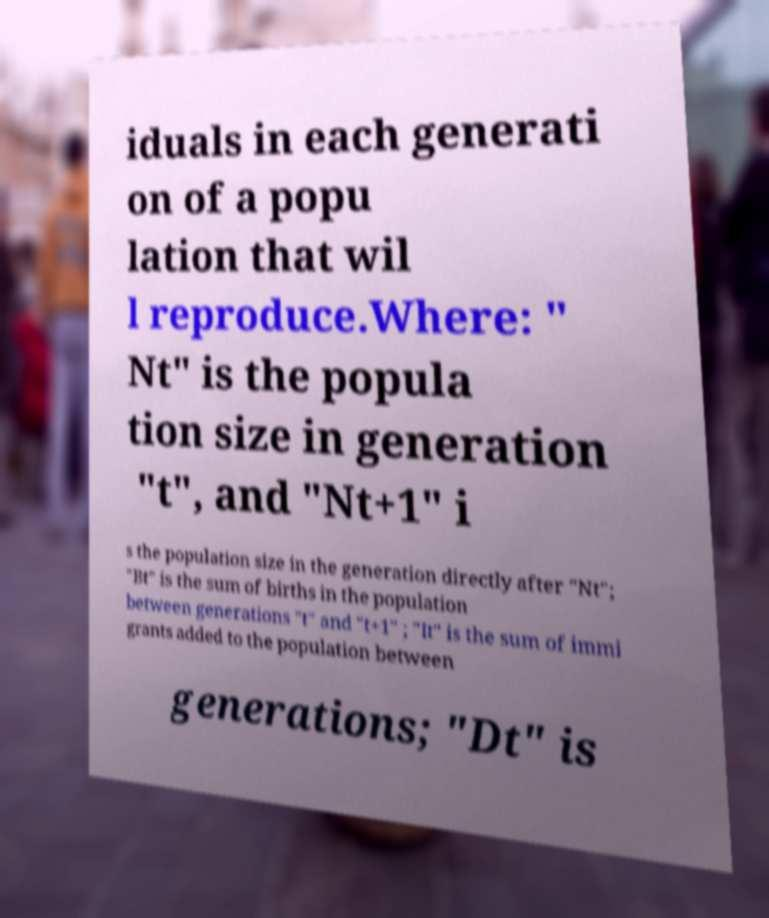What messages or text are displayed in this image? I need them in a readable, typed format. iduals in each generati on of a popu lation that wil l reproduce.Where: " Nt" is the popula tion size in generation "t", and "Nt+1" i s the population size in the generation directly after "Nt"; "Bt" is the sum of births in the population between generations "t" and "t+1" ; "It" is the sum of immi grants added to the population between generations; "Dt" is 